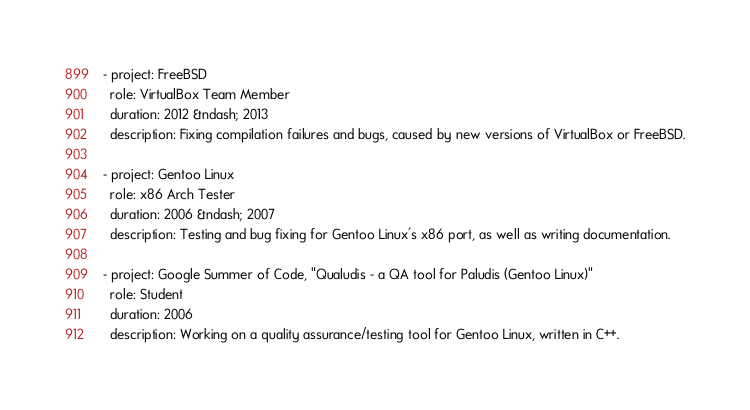Convert code to text. <code><loc_0><loc_0><loc_500><loc_500><_YAML_>- project: FreeBSD
  role: VirtualBox Team Member
  duration: 2012 &ndash; 2013
  description: Fixing compilation failures and bugs, caused by new versions of VirtualBox or FreeBSD.

- project: Gentoo Linux
  role: x86 Arch Tester
  duration: 2006 &ndash; 2007
  description: Testing and bug fixing for Gentoo Linux's x86 port, as well as writing documentation.

- project: Google Summer of Code, "Qualudis - a QA tool for Paludis (Gentoo Linux)"
  role: Student
  duration: 2006
  description: Working on a quality assurance/testing tool for Gentoo Linux, written in C++.

</code> 